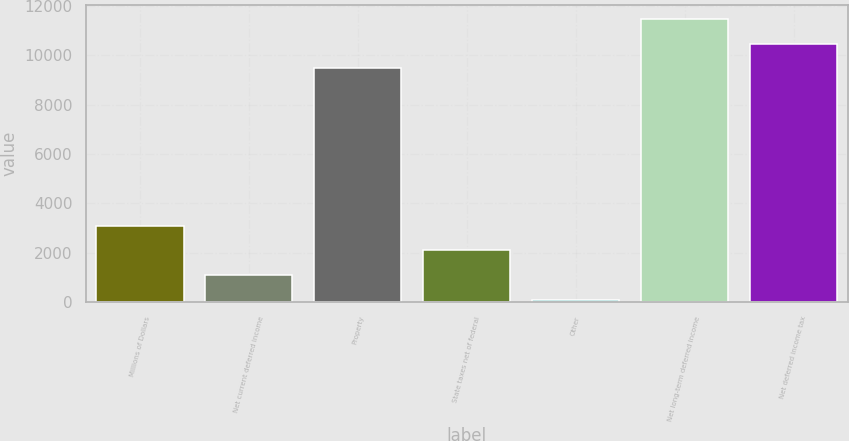Convert chart to OTSL. <chart><loc_0><loc_0><loc_500><loc_500><bar_chart><fcel>Millions of Dollars<fcel>Net current deferred income<fcel>Property<fcel>State taxes net of federal<fcel>Other<fcel>Net long-term deferred income<fcel>Net deferred income tax<nl><fcel>3090.6<fcel>1102.2<fcel>9467<fcel>2096.4<fcel>108<fcel>11455.4<fcel>10461.2<nl></chart> 